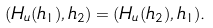Convert formula to latex. <formula><loc_0><loc_0><loc_500><loc_500>( H _ { u } ( h _ { 1 } ) , h _ { 2 } ) = ( H _ { u } ( h _ { 2 } ) , h _ { 1 } ) .</formula> 